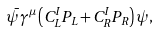<formula> <loc_0><loc_0><loc_500><loc_500>\bar { \psi } \gamma ^ { \mu } \left ( C ^ { I } _ { L } P _ { L } + C ^ { I } _ { R } P _ { R } \right ) \psi ,</formula> 